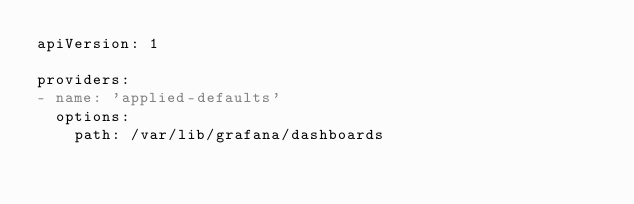Convert code to text. <code><loc_0><loc_0><loc_500><loc_500><_YAML_>apiVersion: 1

providers:
- name: 'applied-defaults'
  options:
    path: /var/lib/grafana/dashboards
</code> 